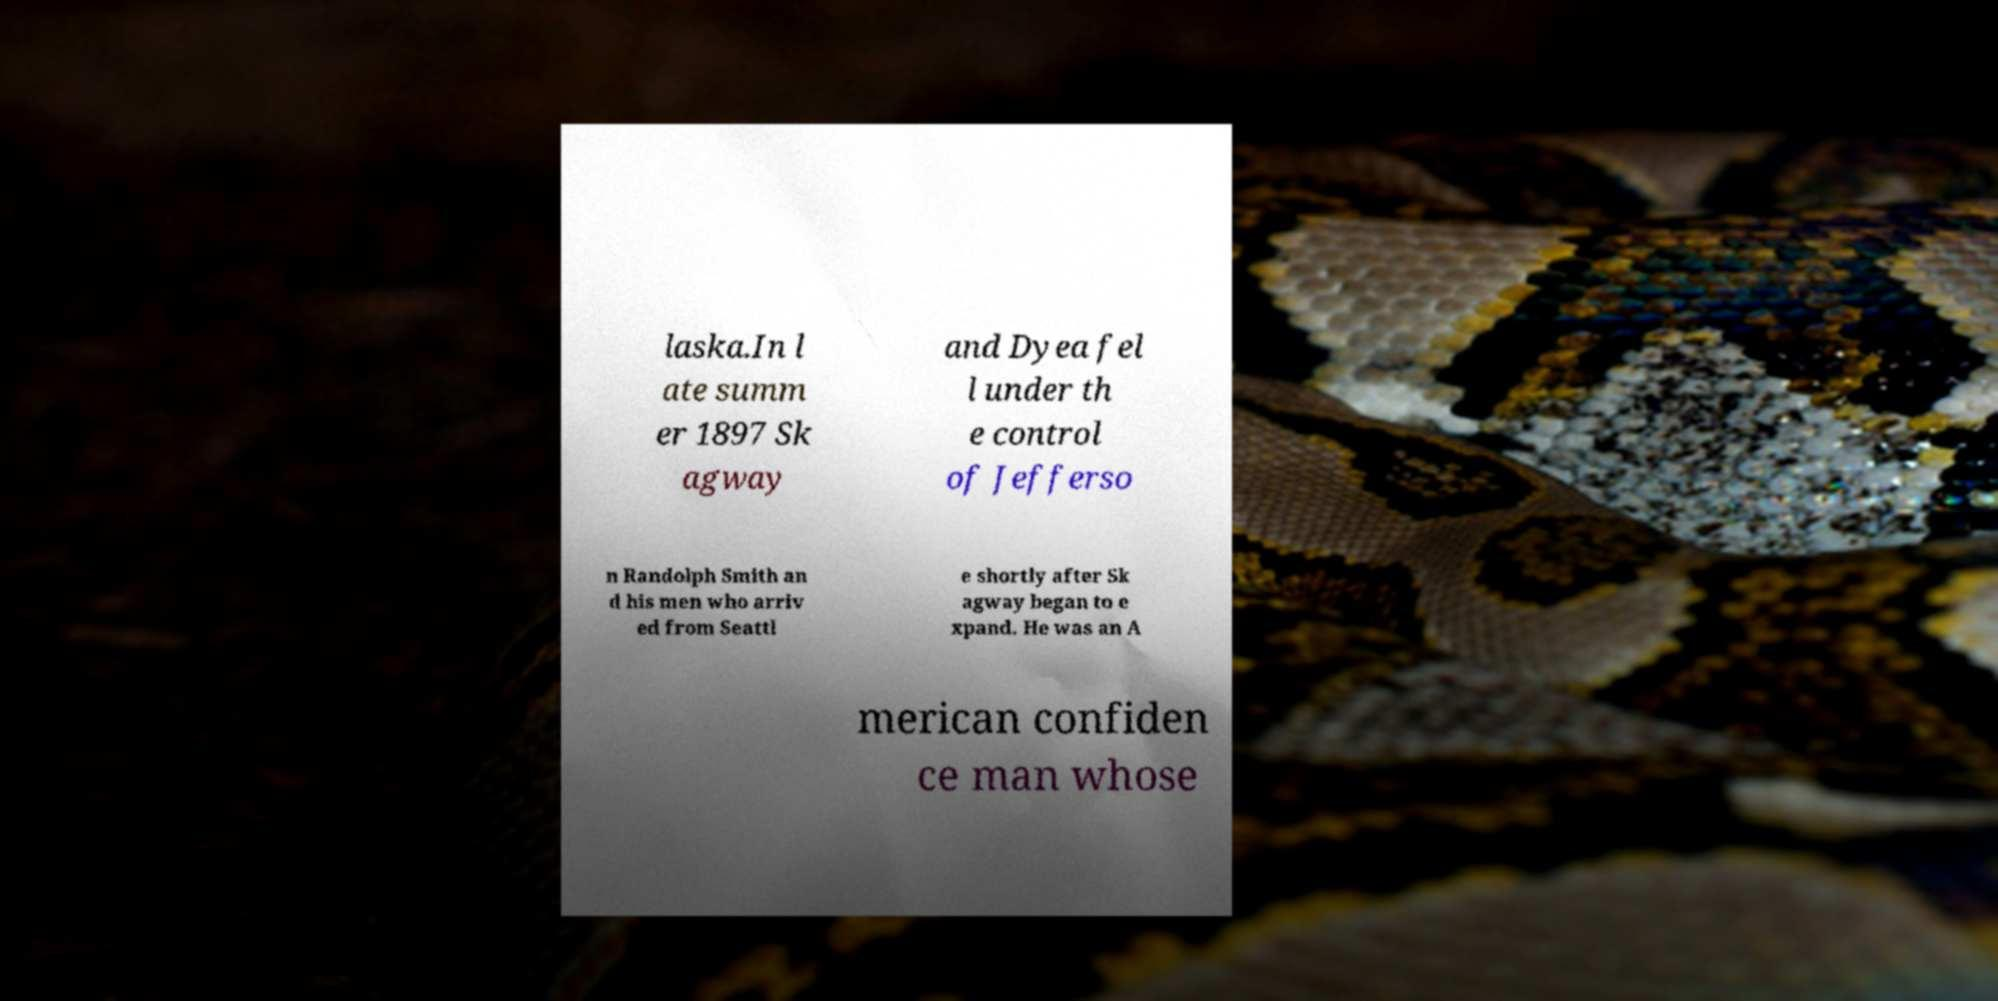I need the written content from this picture converted into text. Can you do that? laska.In l ate summ er 1897 Sk agway and Dyea fel l under th e control of Jefferso n Randolph Smith an d his men who arriv ed from Seattl e shortly after Sk agway began to e xpand. He was an A merican confiden ce man whose 